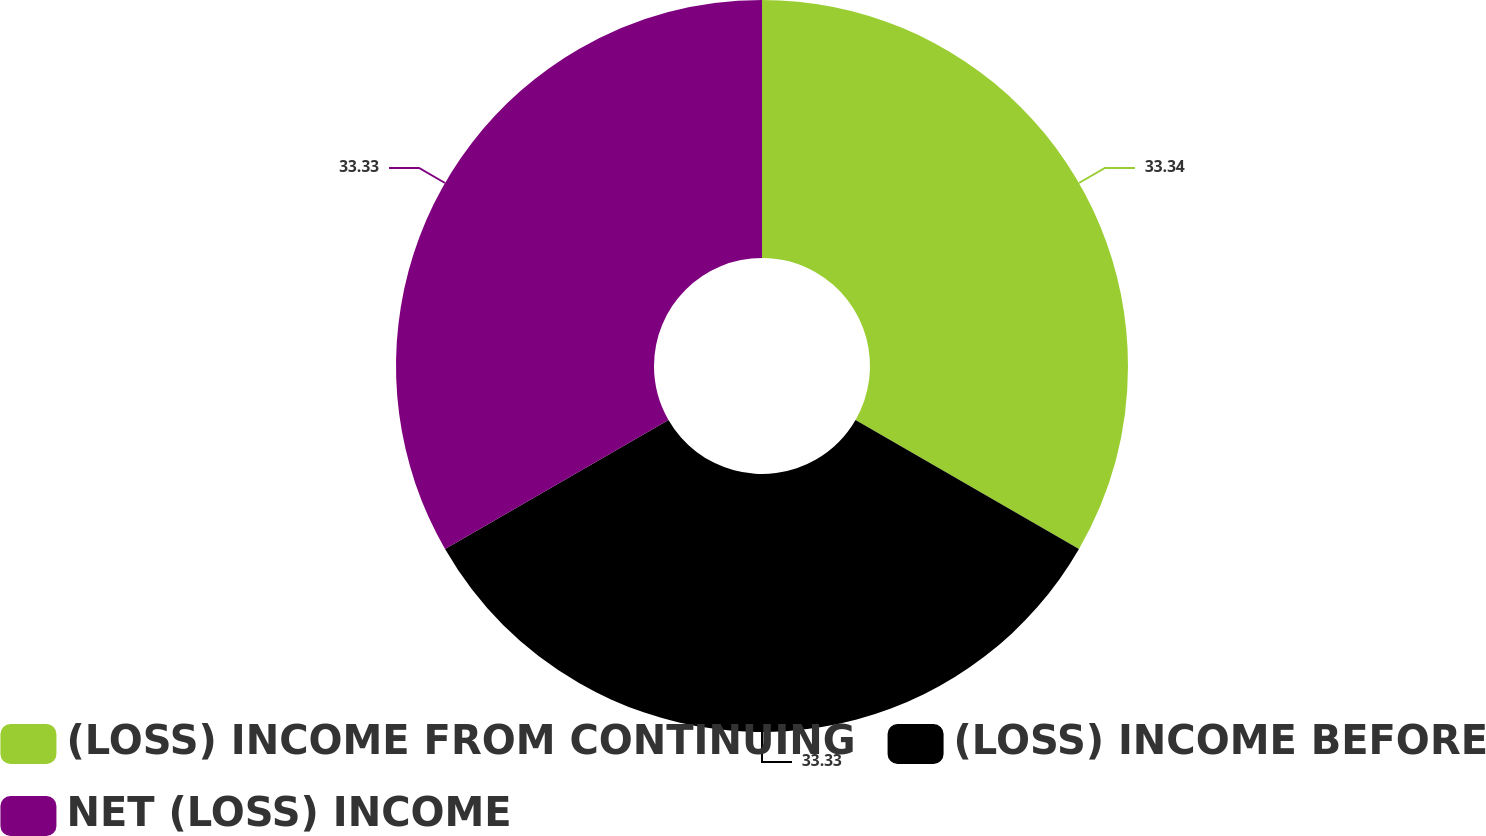Convert chart. <chart><loc_0><loc_0><loc_500><loc_500><pie_chart><fcel>(LOSS) INCOME FROM CONTINUING<fcel>(LOSS) INCOME BEFORE<fcel>NET (LOSS) INCOME<nl><fcel>33.33%<fcel>33.33%<fcel>33.33%<nl></chart> 